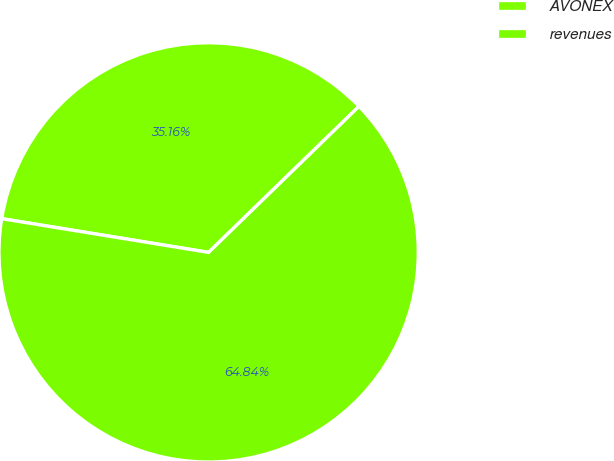Convert chart. <chart><loc_0><loc_0><loc_500><loc_500><pie_chart><fcel>AVONEX<fcel>revenues<nl><fcel>35.16%<fcel>64.84%<nl></chart> 